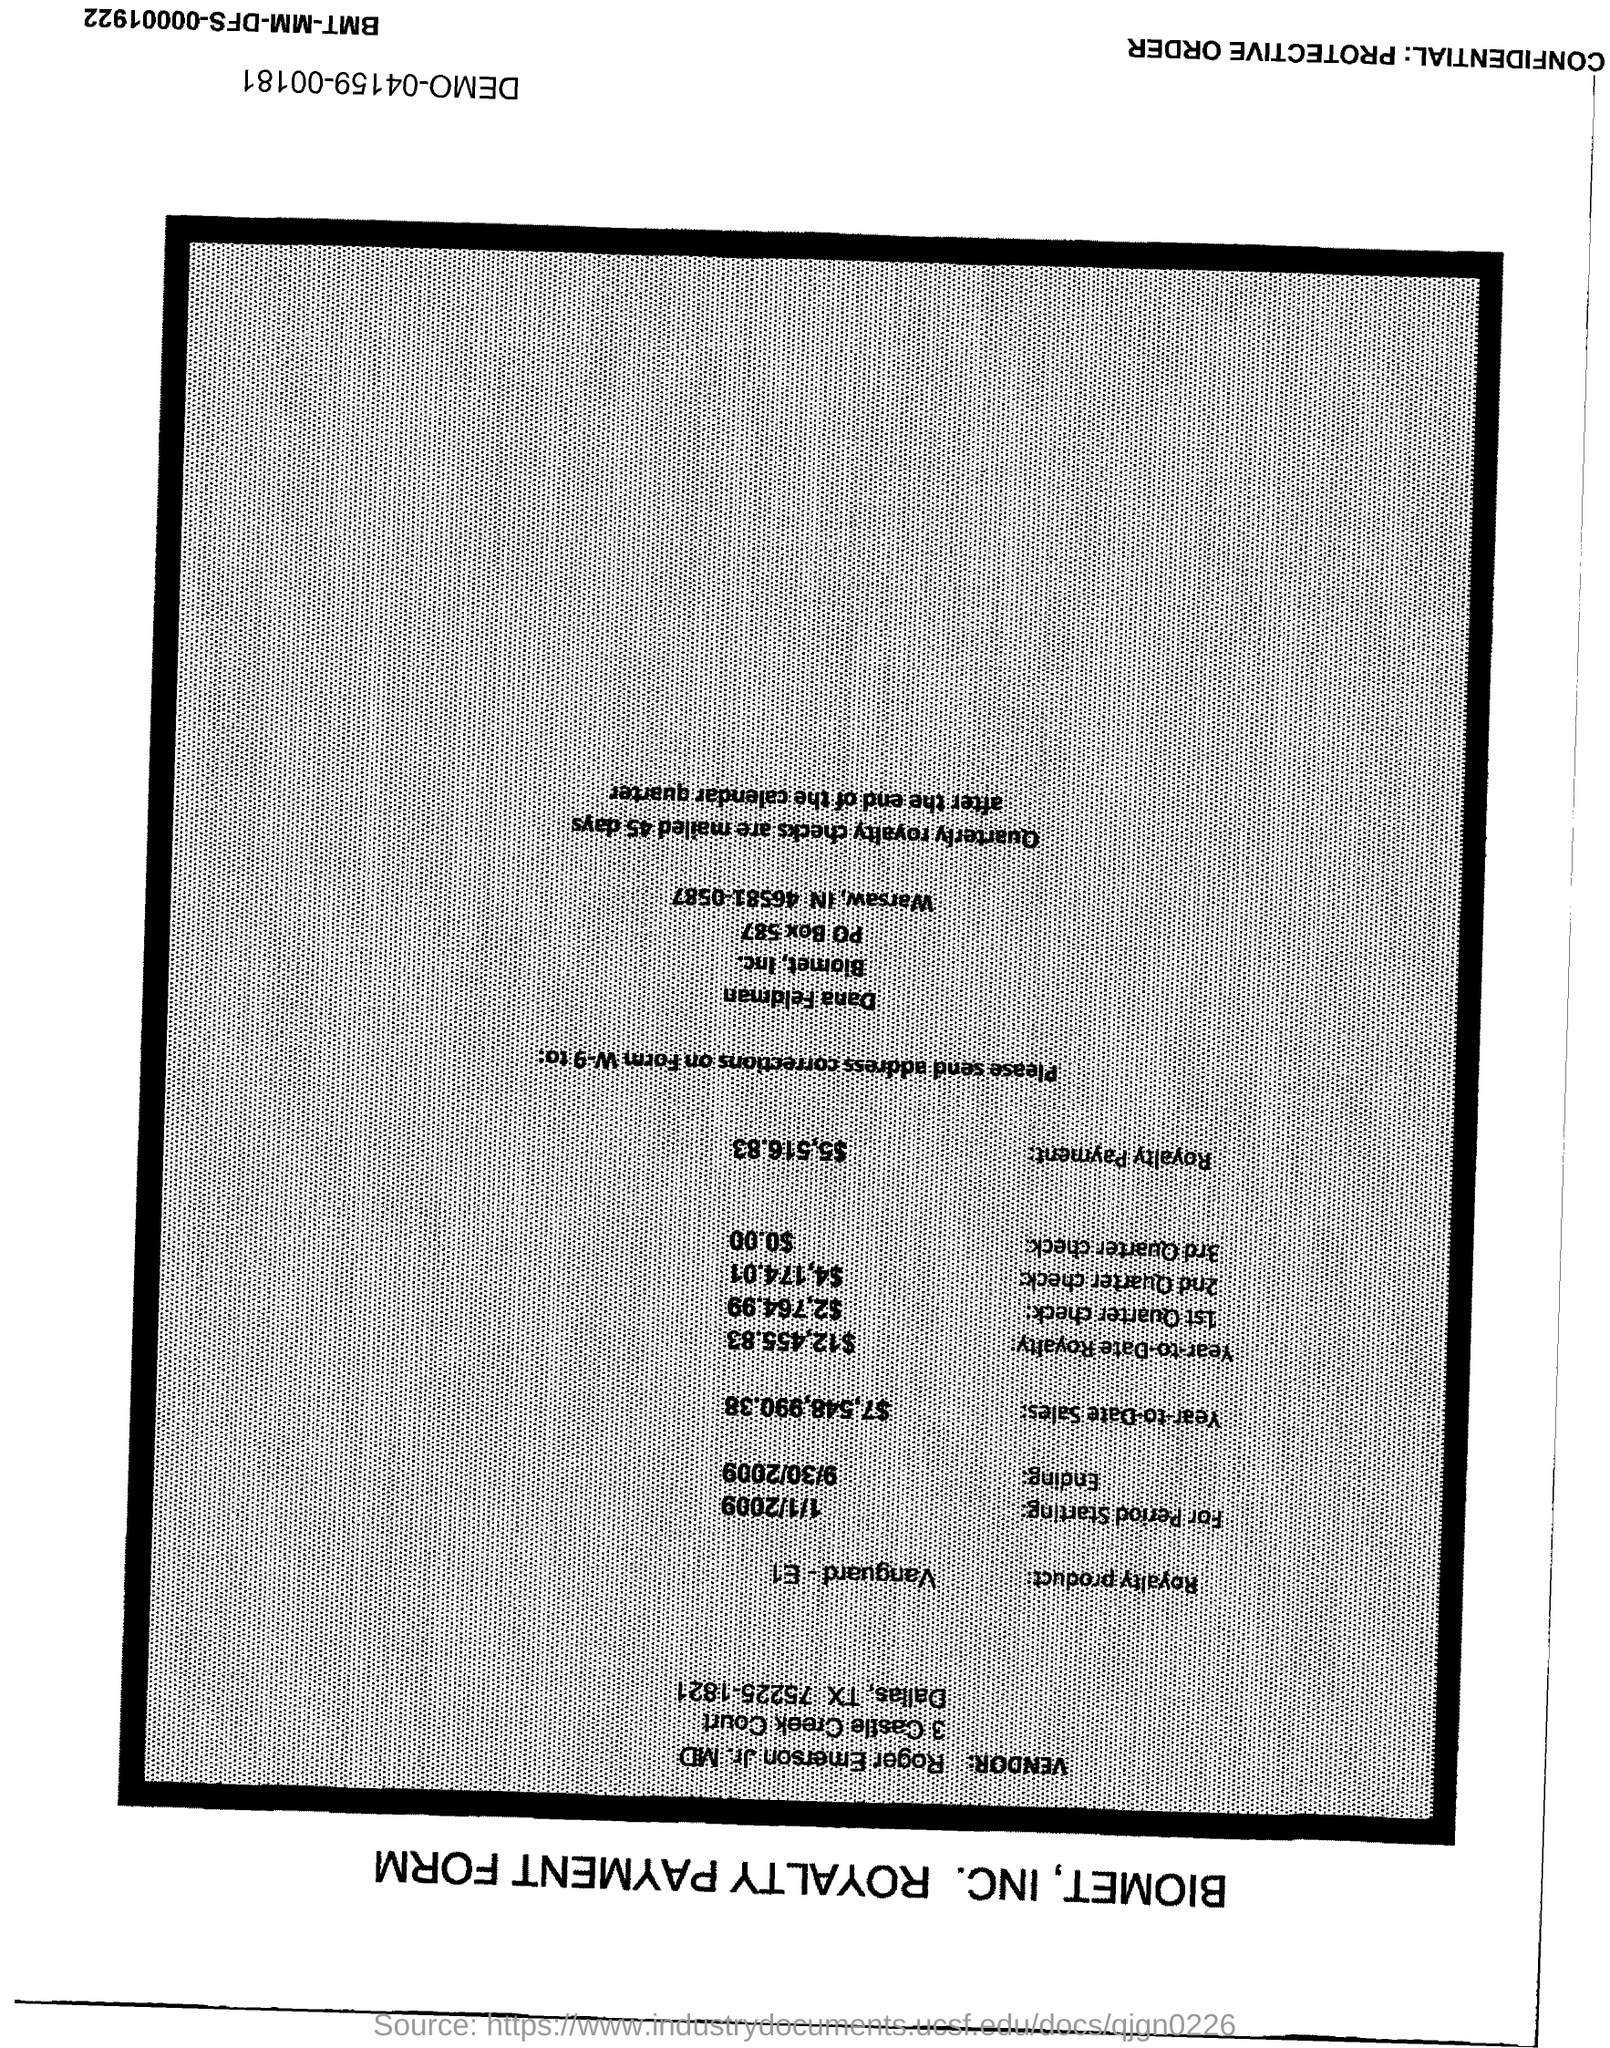How much is Year-to-Date Sales?
Offer a very short reply. $7,548,990.38. How much is Year-to-Date Royalty?
Keep it short and to the point. $12,455.83. How much is the Royalty payment?
Offer a terse response. $5,516.83. 